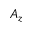Convert formula to latex. <formula><loc_0><loc_0><loc_500><loc_500>A _ { z }</formula> 